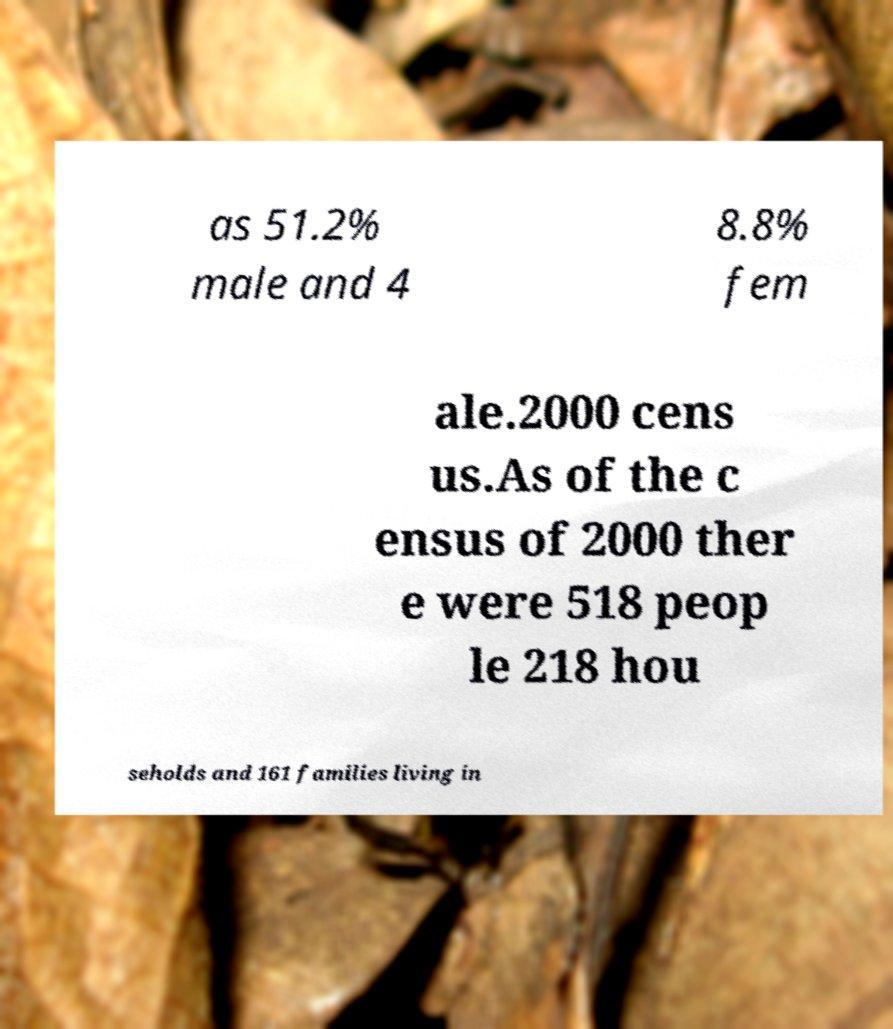Please read and relay the text visible in this image. What does it say? as 51.2% male and 4 8.8% fem ale.2000 cens us.As of the c ensus of 2000 ther e were 518 peop le 218 hou seholds and 161 families living in 